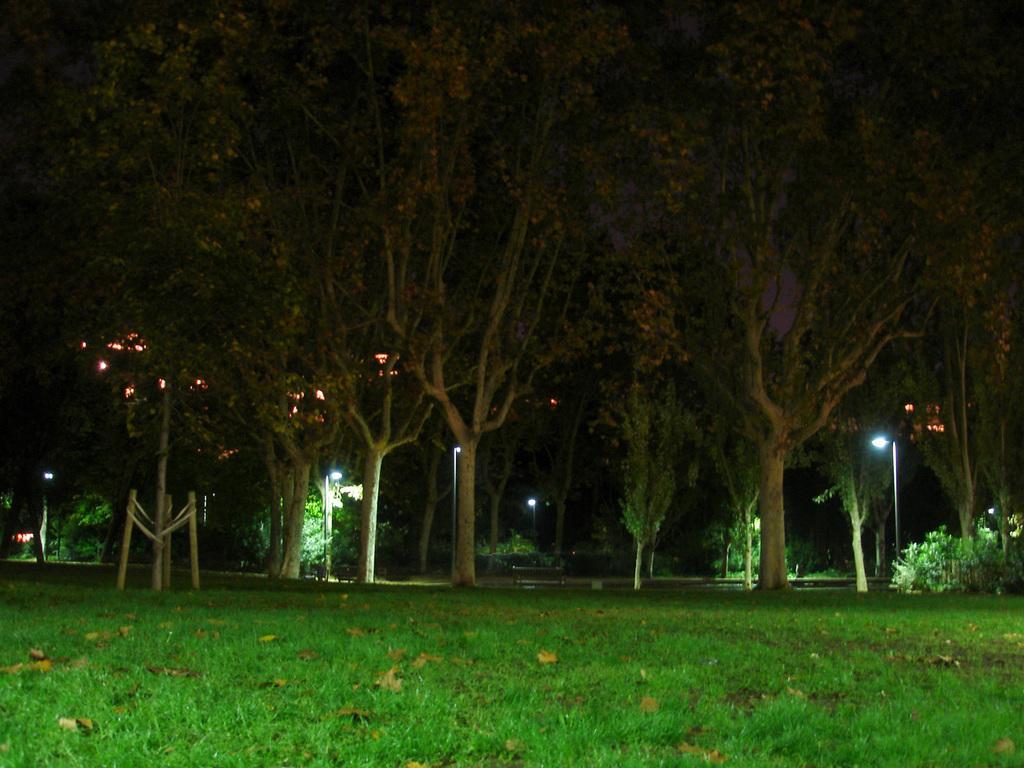Could you give a brief overview of what you see in this image? These are the trees with branches and leaves. I can see the dried leaves lying on the grass. On the right side of the image, I think these are the bushes. I can see the street lights. 